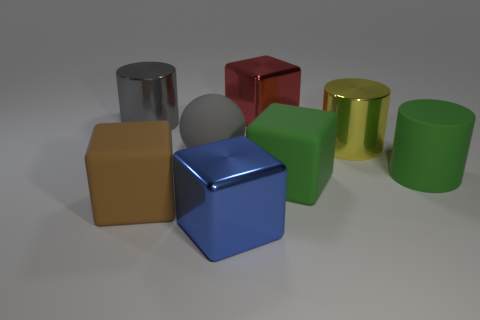How many objects in total are there in the image? The image displays a total of seven objects consisting of various geometric shapes such as cubes and cylinders. 